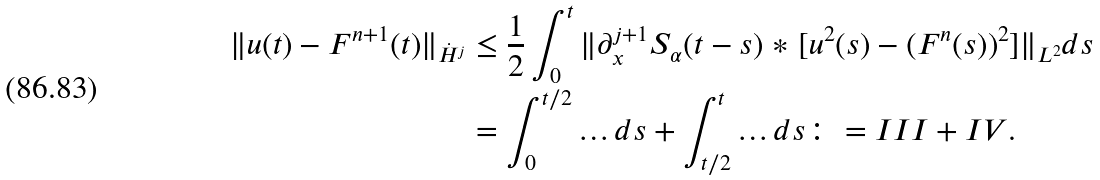<formula> <loc_0><loc_0><loc_500><loc_500>\| u ( t ) - F ^ { n + 1 } ( t ) \| _ { \dot { H } ^ { j } } & \leq \frac { 1 } { 2 } \int _ { 0 } ^ { t } \| \partial _ { x } ^ { j + 1 } S _ { \alpha } ( t - s ) \ast [ u ^ { 2 } ( s ) - ( F ^ { n } ( s ) ) ^ { 2 } ] \| _ { L ^ { 2 } } d s \\ & = \int _ { 0 } ^ { t / 2 } \dots d s + \int _ { t / 2 } ^ { t } \dots d s \colon = I I I + I V .</formula> 